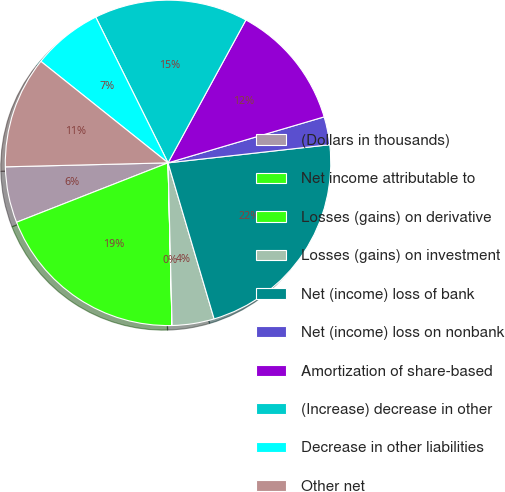Convert chart. <chart><loc_0><loc_0><loc_500><loc_500><pie_chart><fcel>(Dollars in thousands)<fcel>Net income attributable to<fcel>Losses (gains) on derivative<fcel>Losses (gains) on investment<fcel>Net (income) loss of bank<fcel>Net (income) loss on nonbank<fcel>Amortization of share-based<fcel>(Increase) decrease in other<fcel>Decrease in other liabilities<fcel>Other net<nl><fcel>5.56%<fcel>19.44%<fcel>0.01%<fcel>4.17%<fcel>22.21%<fcel>2.78%<fcel>12.5%<fcel>15.27%<fcel>6.95%<fcel>11.11%<nl></chart> 